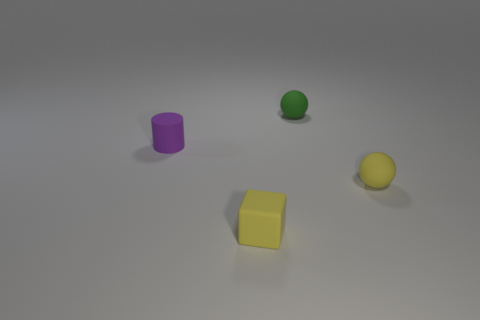How many spheres are the same color as the block?
Your answer should be compact. 1. There is a yellow object that is the same shape as the tiny green thing; what is its size?
Keep it short and to the point. Small. Are there more tiny yellow blocks that are in front of the cylinder than rubber spheres left of the yellow cube?
Your response must be concise. Yes. Are there any other things that have the same shape as the small purple thing?
Your response must be concise. No. The tiny rubber thing that is left of the yellow rubber sphere and in front of the purple rubber thing is what color?
Your answer should be compact. Yellow. There is a tiny rubber object that is behind the purple matte thing; what is its shape?
Your answer should be very brief. Sphere. What is the size of the matte ball on the right side of the small sphere on the left side of the small yellow rubber thing on the right side of the tiny yellow matte block?
Your answer should be very brief. Small. There is a tiny yellow cube that is to the right of the purple rubber object; how many things are on the right side of it?
Keep it short and to the point. 2. How big is the rubber thing that is both to the left of the green matte sphere and in front of the matte cylinder?
Ensure brevity in your answer.  Small. How many rubber things are small yellow balls or cylinders?
Offer a terse response. 2. 